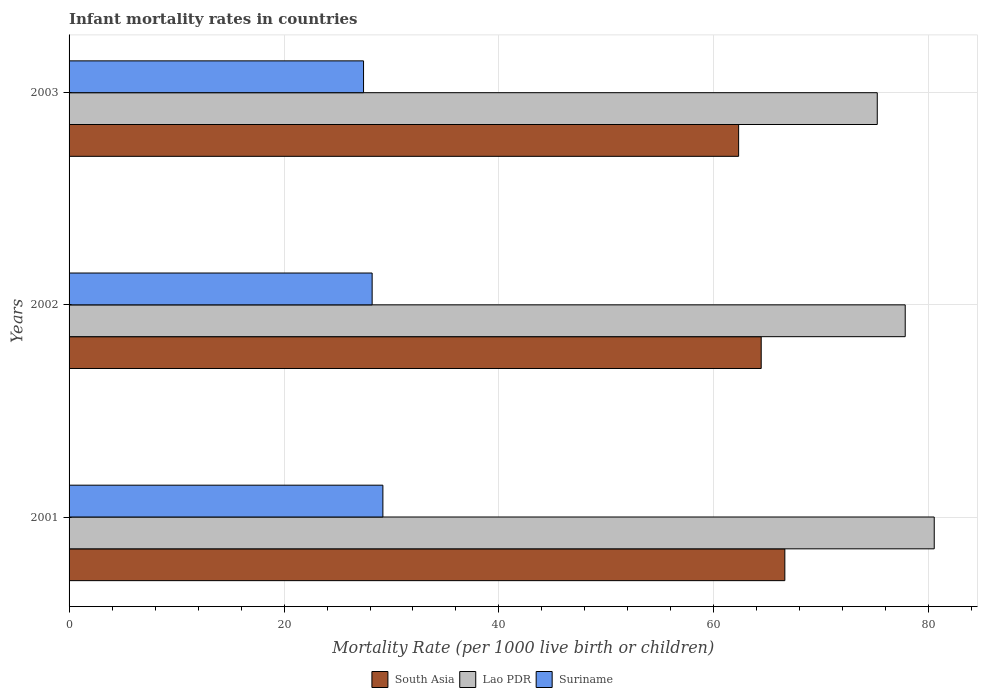How many groups of bars are there?
Make the answer very short. 3. Are the number of bars per tick equal to the number of legend labels?
Provide a short and direct response. Yes. Are the number of bars on each tick of the Y-axis equal?
Offer a very short reply. Yes. How many bars are there on the 2nd tick from the top?
Offer a very short reply. 3. How many bars are there on the 1st tick from the bottom?
Offer a very short reply. 3. In how many cases, is the number of bars for a given year not equal to the number of legend labels?
Your answer should be compact. 0. What is the infant mortality rate in Lao PDR in 2001?
Your answer should be compact. 80.5. Across all years, what is the maximum infant mortality rate in South Asia?
Keep it short and to the point. 66.6. Across all years, what is the minimum infant mortality rate in Lao PDR?
Offer a terse response. 75.2. In which year was the infant mortality rate in Lao PDR minimum?
Your response must be concise. 2003. What is the total infant mortality rate in Suriname in the graph?
Keep it short and to the point. 84.8. What is the difference between the infant mortality rate in Lao PDR in 2001 and that in 2003?
Make the answer very short. 5.3. What is the difference between the infant mortality rate in Suriname in 2001 and the infant mortality rate in South Asia in 2002?
Your answer should be very brief. -35.2. What is the average infant mortality rate in Suriname per year?
Your response must be concise. 28.27. In the year 2003, what is the difference between the infant mortality rate in Lao PDR and infant mortality rate in Suriname?
Your answer should be very brief. 47.8. In how many years, is the infant mortality rate in Lao PDR greater than 4 ?
Your response must be concise. 3. What is the ratio of the infant mortality rate in Lao PDR in 2002 to that in 2003?
Your answer should be compact. 1.03. Is the infant mortality rate in South Asia in 2001 less than that in 2003?
Provide a short and direct response. No. What is the difference between the highest and the second highest infant mortality rate in Lao PDR?
Your answer should be very brief. 2.7. What is the difference between the highest and the lowest infant mortality rate in Suriname?
Provide a succinct answer. 1.8. What does the 1st bar from the top in 2001 represents?
Provide a short and direct response. Suriname. How many bars are there?
Your answer should be very brief. 9. Are all the bars in the graph horizontal?
Offer a very short reply. Yes. What is the difference between two consecutive major ticks on the X-axis?
Offer a very short reply. 20. Are the values on the major ticks of X-axis written in scientific E-notation?
Provide a succinct answer. No. How many legend labels are there?
Provide a short and direct response. 3. How are the legend labels stacked?
Ensure brevity in your answer.  Horizontal. What is the title of the graph?
Provide a short and direct response. Infant mortality rates in countries. What is the label or title of the X-axis?
Keep it short and to the point. Mortality Rate (per 1000 live birth or children). What is the Mortality Rate (per 1000 live birth or children) in South Asia in 2001?
Your answer should be compact. 66.6. What is the Mortality Rate (per 1000 live birth or children) in Lao PDR in 2001?
Provide a succinct answer. 80.5. What is the Mortality Rate (per 1000 live birth or children) of Suriname in 2001?
Make the answer very short. 29.2. What is the Mortality Rate (per 1000 live birth or children) in South Asia in 2002?
Keep it short and to the point. 64.4. What is the Mortality Rate (per 1000 live birth or children) of Lao PDR in 2002?
Give a very brief answer. 77.8. What is the Mortality Rate (per 1000 live birth or children) in Suriname in 2002?
Your answer should be very brief. 28.2. What is the Mortality Rate (per 1000 live birth or children) in South Asia in 2003?
Your answer should be compact. 62.3. What is the Mortality Rate (per 1000 live birth or children) in Lao PDR in 2003?
Ensure brevity in your answer.  75.2. What is the Mortality Rate (per 1000 live birth or children) of Suriname in 2003?
Give a very brief answer. 27.4. Across all years, what is the maximum Mortality Rate (per 1000 live birth or children) in South Asia?
Provide a succinct answer. 66.6. Across all years, what is the maximum Mortality Rate (per 1000 live birth or children) of Lao PDR?
Offer a terse response. 80.5. Across all years, what is the maximum Mortality Rate (per 1000 live birth or children) of Suriname?
Make the answer very short. 29.2. Across all years, what is the minimum Mortality Rate (per 1000 live birth or children) of South Asia?
Your answer should be very brief. 62.3. Across all years, what is the minimum Mortality Rate (per 1000 live birth or children) in Lao PDR?
Make the answer very short. 75.2. Across all years, what is the minimum Mortality Rate (per 1000 live birth or children) of Suriname?
Your answer should be very brief. 27.4. What is the total Mortality Rate (per 1000 live birth or children) in South Asia in the graph?
Your answer should be compact. 193.3. What is the total Mortality Rate (per 1000 live birth or children) in Lao PDR in the graph?
Provide a short and direct response. 233.5. What is the total Mortality Rate (per 1000 live birth or children) of Suriname in the graph?
Your response must be concise. 84.8. What is the difference between the Mortality Rate (per 1000 live birth or children) in South Asia in 2001 and that in 2002?
Offer a terse response. 2.2. What is the difference between the Mortality Rate (per 1000 live birth or children) of Lao PDR in 2001 and that in 2002?
Give a very brief answer. 2.7. What is the difference between the Mortality Rate (per 1000 live birth or children) in Lao PDR in 2001 and that in 2003?
Offer a terse response. 5.3. What is the difference between the Mortality Rate (per 1000 live birth or children) of Suriname in 2002 and that in 2003?
Your response must be concise. 0.8. What is the difference between the Mortality Rate (per 1000 live birth or children) of South Asia in 2001 and the Mortality Rate (per 1000 live birth or children) of Lao PDR in 2002?
Offer a very short reply. -11.2. What is the difference between the Mortality Rate (per 1000 live birth or children) of South Asia in 2001 and the Mortality Rate (per 1000 live birth or children) of Suriname in 2002?
Offer a terse response. 38.4. What is the difference between the Mortality Rate (per 1000 live birth or children) of Lao PDR in 2001 and the Mortality Rate (per 1000 live birth or children) of Suriname in 2002?
Offer a very short reply. 52.3. What is the difference between the Mortality Rate (per 1000 live birth or children) of South Asia in 2001 and the Mortality Rate (per 1000 live birth or children) of Suriname in 2003?
Your response must be concise. 39.2. What is the difference between the Mortality Rate (per 1000 live birth or children) of Lao PDR in 2001 and the Mortality Rate (per 1000 live birth or children) of Suriname in 2003?
Provide a succinct answer. 53.1. What is the difference between the Mortality Rate (per 1000 live birth or children) in South Asia in 2002 and the Mortality Rate (per 1000 live birth or children) in Lao PDR in 2003?
Offer a very short reply. -10.8. What is the difference between the Mortality Rate (per 1000 live birth or children) of South Asia in 2002 and the Mortality Rate (per 1000 live birth or children) of Suriname in 2003?
Offer a terse response. 37. What is the difference between the Mortality Rate (per 1000 live birth or children) of Lao PDR in 2002 and the Mortality Rate (per 1000 live birth or children) of Suriname in 2003?
Offer a very short reply. 50.4. What is the average Mortality Rate (per 1000 live birth or children) of South Asia per year?
Give a very brief answer. 64.43. What is the average Mortality Rate (per 1000 live birth or children) of Lao PDR per year?
Keep it short and to the point. 77.83. What is the average Mortality Rate (per 1000 live birth or children) in Suriname per year?
Your answer should be compact. 28.27. In the year 2001, what is the difference between the Mortality Rate (per 1000 live birth or children) of South Asia and Mortality Rate (per 1000 live birth or children) of Suriname?
Keep it short and to the point. 37.4. In the year 2001, what is the difference between the Mortality Rate (per 1000 live birth or children) of Lao PDR and Mortality Rate (per 1000 live birth or children) of Suriname?
Ensure brevity in your answer.  51.3. In the year 2002, what is the difference between the Mortality Rate (per 1000 live birth or children) of South Asia and Mortality Rate (per 1000 live birth or children) of Suriname?
Ensure brevity in your answer.  36.2. In the year 2002, what is the difference between the Mortality Rate (per 1000 live birth or children) of Lao PDR and Mortality Rate (per 1000 live birth or children) of Suriname?
Ensure brevity in your answer.  49.6. In the year 2003, what is the difference between the Mortality Rate (per 1000 live birth or children) of South Asia and Mortality Rate (per 1000 live birth or children) of Lao PDR?
Provide a succinct answer. -12.9. In the year 2003, what is the difference between the Mortality Rate (per 1000 live birth or children) in South Asia and Mortality Rate (per 1000 live birth or children) in Suriname?
Give a very brief answer. 34.9. In the year 2003, what is the difference between the Mortality Rate (per 1000 live birth or children) in Lao PDR and Mortality Rate (per 1000 live birth or children) in Suriname?
Keep it short and to the point. 47.8. What is the ratio of the Mortality Rate (per 1000 live birth or children) of South Asia in 2001 to that in 2002?
Offer a very short reply. 1.03. What is the ratio of the Mortality Rate (per 1000 live birth or children) in Lao PDR in 2001 to that in 2002?
Ensure brevity in your answer.  1.03. What is the ratio of the Mortality Rate (per 1000 live birth or children) in Suriname in 2001 to that in 2002?
Your answer should be very brief. 1.04. What is the ratio of the Mortality Rate (per 1000 live birth or children) in South Asia in 2001 to that in 2003?
Offer a very short reply. 1.07. What is the ratio of the Mortality Rate (per 1000 live birth or children) in Lao PDR in 2001 to that in 2003?
Offer a terse response. 1.07. What is the ratio of the Mortality Rate (per 1000 live birth or children) in Suriname in 2001 to that in 2003?
Provide a short and direct response. 1.07. What is the ratio of the Mortality Rate (per 1000 live birth or children) in South Asia in 2002 to that in 2003?
Offer a very short reply. 1.03. What is the ratio of the Mortality Rate (per 1000 live birth or children) in Lao PDR in 2002 to that in 2003?
Your answer should be compact. 1.03. What is the ratio of the Mortality Rate (per 1000 live birth or children) in Suriname in 2002 to that in 2003?
Ensure brevity in your answer.  1.03. What is the difference between the highest and the second highest Mortality Rate (per 1000 live birth or children) in South Asia?
Your response must be concise. 2.2. What is the difference between the highest and the second highest Mortality Rate (per 1000 live birth or children) of Lao PDR?
Your answer should be compact. 2.7. What is the difference between the highest and the lowest Mortality Rate (per 1000 live birth or children) in Lao PDR?
Your answer should be very brief. 5.3. 